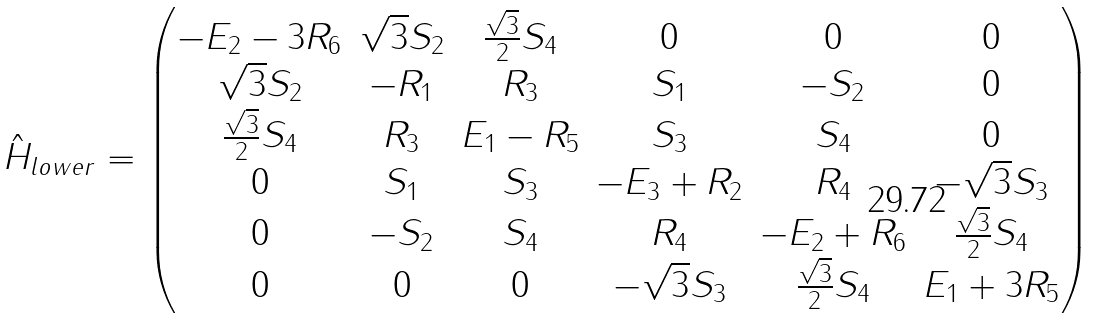<formula> <loc_0><loc_0><loc_500><loc_500>\hat { H } _ { l o w e r } = \begin{pmatrix} - E _ { 2 } - 3 R _ { 6 } & \sqrt { 3 } S _ { 2 } & \frac { \sqrt { 3 } } { 2 } S _ { 4 } & 0 & 0 & 0 \\ \sqrt { 3 } S _ { 2 } & - R _ { 1 } & R _ { 3 } & S _ { 1 } & - S _ { 2 } & 0 \\ \frac { \sqrt { 3 } } { 2 } S _ { 4 } & R _ { 3 } & E _ { 1 } - R _ { 5 } & S _ { 3 } & S _ { 4 } & 0 \\ 0 & S _ { 1 } & S _ { 3 } & - E _ { 3 } + R _ { 2 } & R _ { 4 } & - \sqrt { 3 } S _ { 3 } \\ 0 & - S _ { 2 } & S _ { 4 } & R _ { 4 } & - E _ { 2 } + R _ { 6 } & \frac { \sqrt { 3 } } { 2 } S _ { 4 } \\ 0 & 0 & 0 & - \sqrt { 3 } S _ { 3 } & \frac { \sqrt { 3 } } { 2 } S _ { 4 } & E _ { 1 } + 3 R _ { 5 } \\ \end{pmatrix}</formula> 